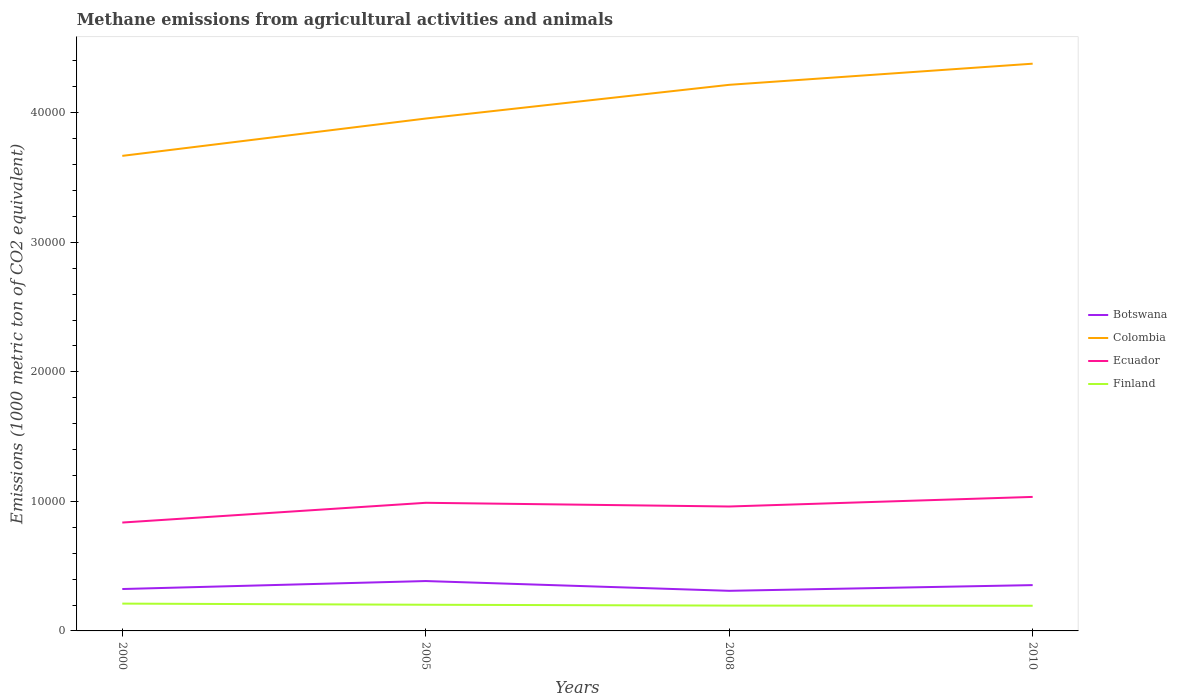Does the line corresponding to Ecuador intersect with the line corresponding to Finland?
Provide a short and direct response. No. Is the number of lines equal to the number of legend labels?
Offer a terse response. Yes. Across all years, what is the maximum amount of methane emitted in Botswana?
Keep it short and to the point. 3096.4. In which year was the amount of methane emitted in Finland maximum?
Keep it short and to the point. 2010. What is the total amount of methane emitted in Colombia in the graph?
Provide a short and direct response. -4235.6. What is the difference between the highest and the second highest amount of methane emitted in Finland?
Make the answer very short. 164.3. What is the difference between the highest and the lowest amount of methane emitted in Finland?
Provide a succinct answer. 2. Is the amount of methane emitted in Finland strictly greater than the amount of methane emitted in Colombia over the years?
Keep it short and to the point. Yes. How many lines are there?
Provide a succinct answer. 4. How many years are there in the graph?
Offer a very short reply. 4. What is the difference between two consecutive major ticks on the Y-axis?
Offer a terse response. 10000. Are the values on the major ticks of Y-axis written in scientific E-notation?
Give a very brief answer. No. Where does the legend appear in the graph?
Ensure brevity in your answer.  Center right. How many legend labels are there?
Your answer should be compact. 4. What is the title of the graph?
Keep it short and to the point. Methane emissions from agricultural activities and animals. Does "Peru" appear as one of the legend labels in the graph?
Keep it short and to the point. No. What is the label or title of the Y-axis?
Your answer should be very brief. Emissions (1000 metric ton of CO2 equivalent). What is the Emissions (1000 metric ton of CO2 equivalent) of Botswana in 2000?
Your answer should be very brief. 3234. What is the Emissions (1000 metric ton of CO2 equivalent) in Colombia in 2000?
Offer a very short reply. 3.67e+04. What is the Emissions (1000 metric ton of CO2 equivalent) in Ecuador in 2000?
Your answer should be very brief. 8366.7. What is the Emissions (1000 metric ton of CO2 equivalent) in Finland in 2000?
Provide a short and direct response. 2107.9. What is the Emissions (1000 metric ton of CO2 equivalent) in Botswana in 2005?
Give a very brief answer. 3850.6. What is the Emissions (1000 metric ton of CO2 equivalent) in Colombia in 2005?
Make the answer very short. 3.96e+04. What is the Emissions (1000 metric ton of CO2 equivalent) in Ecuador in 2005?
Keep it short and to the point. 9891. What is the Emissions (1000 metric ton of CO2 equivalent) in Finland in 2005?
Give a very brief answer. 2020.8. What is the Emissions (1000 metric ton of CO2 equivalent) of Botswana in 2008?
Provide a succinct answer. 3096.4. What is the Emissions (1000 metric ton of CO2 equivalent) of Colombia in 2008?
Keep it short and to the point. 4.22e+04. What is the Emissions (1000 metric ton of CO2 equivalent) of Ecuador in 2008?
Your response must be concise. 9604.8. What is the Emissions (1000 metric ton of CO2 equivalent) of Finland in 2008?
Your answer should be very brief. 1955.7. What is the Emissions (1000 metric ton of CO2 equivalent) in Botswana in 2010?
Your answer should be compact. 3536.6. What is the Emissions (1000 metric ton of CO2 equivalent) in Colombia in 2010?
Your answer should be compact. 4.38e+04. What is the Emissions (1000 metric ton of CO2 equivalent) in Ecuador in 2010?
Your response must be concise. 1.03e+04. What is the Emissions (1000 metric ton of CO2 equivalent) of Finland in 2010?
Offer a very short reply. 1943.6. Across all years, what is the maximum Emissions (1000 metric ton of CO2 equivalent) in Botswana?
Offer a very short reply. 3850.6. Across all years, what is the maximum Emissions (1000 metric ton of CO2 equivalent) of Colombia?
Keep it short and to the point. 4.38e+04. Across all years, what is the maximum Emissions (1000 metric ton of CO2 equivalent) in Ecuador?
Provide a succinct answer. 1.03e+04. Across all years, what is the maximum Emissions (1000 metric ton of CO2 equivalent) in Finland?
Your answer should be very brief. 2107.9. Across all years, what is the minimum Emissions (1000 metric ton of CO2 equivalent) of Botswana?
Give a very brief answer. 3096.4. Across all years, what is the minimum Emissions (1000 metric ton of CO2 equivalent) in Colombia?
Make the answer very short. 3.67e+04. Across all years, what is the minimum Emissions (1000 metric ton of CO2 equivalent) in Ecuador?
Make the answer very short. 8366.7. Across all years, what is the minimum Emissions (1000 metric ton of CO2 equivalent) of Finland?
Give a very brief answer. 1943.6. What is the total Emissions (1000 metric ton of CO2 equivalent) in Botswana in the graph?
Ensure brevity in your answer.  1.37e+04. What is the total Emissions (1000 metric ton of CO2 equivalent) in Colombia in the graph?
Your answer should be very brief. 1.62e+05. What is the total Emissions (1000 metric ton of CO2 equivalent) in Ecuador in the graph?
Your answer should be compact. 3.82e+04. What is the total Emissions (1000 metric ton of CO2 equivalent) of Finland in the graph?
Your answer should be compact. 8028. What is the difference between the Emissions (1000 metric ton of CO2 equivalent) in Botswana in 2000 and that in 2005?
Give a very brief answer. -616.6. What is the difference between the Emissions (1000 metric ton of CO2 equivalent) of Colombia in 2000 and that in 2005?
Your answer should be compact. -2881.6. What is the difference between the Emissions (1000 metric ton of CO2 equivalent) in Ecuador in 2000 and that in 2005?
Provide a short and direct response. -1524.3. What is the difference between the Emissions (1000 metric ton of CO2 equivalent) in Finland in 2000 and that in 2005?
Your answer should be compact. 87.1. What is the difference between the Emissions (1000 metric ton of CO2 equivalent) of Botswana in 2000 and that in 2008?
Your answer should be very brief. 137.6. What is the difference between the Emissions (1000 metric ton of CO2 equivalent) in Colombia in 2000 and that in 2008?
Keep it short and to the point. -5485.2. What is the difference between the Emissions (1000 metric ton of CO2 equivalent) of Ecuador in 2000 and that in 2008?
Offer a terse response. -1238.1. What is the difference between the Emissions (1000 metric ton of CO2 equivalent) of Finland in 2000 and that in 2008?
Offer a terse response. 152.2. What is the difference between the Emissions (1000 metric ton of CO2 equivalent) of Botswana in 2000 and that in 2010?
Offer a terse response. -302.6. What is the difference between the Emissions (1000 metric ton of CO2 equivalent) in Colombia in 2000 and that in 2010?
Ensure brevity in your answer.  -7117.2. What is the difference between the Emissions (1000 metric ton of CO2 equivalent) in Ecuador in 2000 and that in 2010?
Your response must be concise. -1979.1. What is the difference between the Emissions (1000 metric ton of CO2 equivalent) of Finland in 2000 and that in 2010?
Give a very brief answer. 164.3. What is the difference between the Emissions (1000 metric ton of CO2 equivalent) in Botswana in 2005 and that in 2008?
Your answer should be compact. 754.2. What is the difference between the Emissions (1000 metric ton of CO2 equivalent) of Colombia in 2005 and that in 2008?
Your response must be concise. -2603.6. What is the difference between the Emissions (1000 metric ton of CO2 equivalent) in Ecuador in 2005 and that in 2008?
Offer a very short reply. 286.2. What is the difference between the Emissions (1000 metric ton of CO2 equivalent) in Finland in 2005 and that in 2008?
Ensure brevity in your answer.  65.1. What is the difference between the Emissions (1000 metric ton of CO2 equivalent) of Botswana in 2005 and that in 2010?
Make the answer very short. 314. What is the difference between the Emissions (1000 metric ton of CO2 equivalent) of Colombia in 2005 and that in 2010?
Give a very brief answer. -4235.6. What is the difference between the Emissions (1000 metric ton of CO2 equivalent) of Ecuador in 2005 and that in 2010?
Offer a terse response. -454.8. What is the difference between the Emissions (1000 metric ton of CO2 equivalent) in Finland in 2005 and that in 2010?
Offer a very short reply. 77.2. What is the difference between the Emissions (1000 metric ton of CO2 equivalent) of Botswana in 2008 and that in 2010?
Provide a short and direct response. -440.2. What is the difference between the Emissions (1000 metric ton of CO2 equivalent) of Colombia in 2008 and that in 2010?
Ensure brevity in your answer.  -1632. What is the difference between the Emissions (1000 metric ton of CO2 equivalent) in Ecuador in 2008 and that in 2010?
Keep it short and to the point. -741. What is the difference between the Emissions (1000 metric ton of CO2 equivalent) in Finland in 2008 and that in 2010?
Offer a very short reply. 12.1. What is the difference between the Emissions (1000 metric ton of CO2 equivalent) of Botswana in 2000 and the Emissions (1000 metric ton of CO2 equivalent) of Colombia in 2005?
Your answer should be compact. -3.63e+04. What is the difference between the Emissions (1000 metric ton of CO2 equivalent) of Botswana in 2000 and the Emissions (1000 metric ton of CO2 equivalent) of Ecuador in 2005?
Ensure brevity in your answer.  -6657. What is the difference between the Emissions (1000 metric ton of CO2 equivalent) of Botswana in 2000 and the Emissions (1000 metric ton of CO2 equivalent) of Finland in 2005?
Offer a very short reply. 1213.2. What is the difference between the Emissions (1000 metric ton of CO2 equivalent) of Colombia in 2000 and the Emissions (1000 metric ton of CO2 equivalent) of Ecuador in 2005?
Your answer should be compact. 2.68e+04. What is the difference between the Emissions (1000 metric ton of CO2 equivalent) of Colombia in 2000 and the Emissions (1000 metric ton of CO2 equivalent) of Finland in 2005?
Offer a terse response. 3.47e+04. What is the difference between the Emissions (1000 metric ton of CO2 equivalent) of Ecuador in 2000 and the Emissions (1000 metric ton of CO2 equivalent) of Finland in 2005?
Your answer should be compact. 6345.9. What is the difference between the Emissions (1000 metric ton of CO2 equivalent) in Botswana in 2000 and the Emissions (1000 metric ton of CO2 equivalent) in Colombia in 2008?
Your answer should be very brief. -3.89e+04. What is the difference between the Emissions (1000 metric ton of CO2 equivalent) of Botswana in 2000 and the Emissions (1000 metric ton of CO2 equivalent) of Ecuador in 2008?
Give a very brief answer. -6370.8. What is the difference between the Emissions (1000 metric ton of CO2 equivalent) of Botswana in 2000 and the Emissions (1000 metric ton of CO2 equivalent) of Finland in 2008?
Your answer should be compact. 1278.3. What is the difference between the Emissions (1000 metric ton of CO2 equivalent) in Colombia in 2000 and the Emissions (1000 metric ton of CO2 equivalent) in Ecuador in 2008?
Your response must be concise. 2.71e+04. What is the difference between the Emissions (1000 metric ton of CO2 equivalent) of Colombia in 2000 and the Emissions (1000 metric ton of CO2 equivalent) of Finland in 2008?
Offer a terse response. 3.47e+04. What is the difference between the Emissions (1000 metric ton of CO2 equivalent) in Ecuador in 2000 and the Emissions (1000 metric ton of CO2 equivalent) in Finland in 2008?
Offer a terse response. 6411. What is the difference between the Emissions (1000 metric ton of CO2 equivalent) of Botswana in 2000 and the Emissions (1000 metric ton of CO2 equivalent) of Colombia in 2010?
Your answer should be compact. -4.06e+04. What is the difference between the Emissions (1000 metric ton of CO2 equivalent) in Botswana in 2000 and the Emissions (1000 metric ton of CO2 equivalent) in Ecuador in 2010?
Offer a terse response. -7111.8. What is the difference between the Emissions (1000 metric ton of CO2 equivalent) in Botswana in 2000 and the Emissions (1000 metric ton of CO2 equivalent) in Finland in 2010?
Offer a terse response. 1290.4. What is the difference between the Emissions (1000 metric ton of CO2 equivalent) in Colombia in 2000 and the Emissions (1000 metric ton of CO2 equivalent) in Ecuador in 2010?
Keep it short and to the point. 2.63e+04. What is the difference between the Emissions (1000 metric ton of CO2 equivalent) in Colombia in 2000 and the Emissions (1000 metric ton of CO2 equivalent) in Finland in 2010?
Make the answer very short. 3.47e+04. What is the difference between the Emissions (1000 metric ton of CO2 equivalent) of Ecuador in 2000 and the Emissions (1000 metric ton of CO2 equivalent) of Finland in 2010?
Your response must be concise. 6423.1. What is the difference between the Emissions (1000 metric ton of CO2 equivalent) in Botswana in 2005 and the Emissions (1000 metric ton of CO2 equivalent) in Colombia in 2008?
Ensure brevity in your answer.  -3.83e+04. What is the difference between the Emissions (1000 metric ton of CO2 equivalent) in Botswana in 2005 and the Emissions (1000 metric ton of CO2 equivalent) in Ecuador in 2008?
Provide a short and direct response. -5754.2. What is the difference between the Emissions (1000 metric ton of CO2 equivalent) of Botswana in 2005 and the Emissions (1000 metric ton of CO2 equivalent) of Finland in 2008?
Offer a terse response. 1894.9. What is the difference between the Emissions (1000 metric ton of CO2 equivalent) of Colombia in 2005 and the Emissions (1000 metric ton of CO2 equivalent) of Ecuador in 2008?
Keep it short and to the point. 3.00e+04. What is the difference between the Emissions (1000 metric ton of CO2 equivalent) in Colombia in 2005 and the Emissions (1000 metric ton of CO2 equivalent) in Finland in 2008?
Your answer should be compact. 3.76e+04. What is the difference between the Emissions (1000 metric ton of CO2 equivalent) of Ecuador in 2005 and the Emissions (1000 metric ton of CO2 equivalent) of Finland in 2008?
Your response must be concise. 7935.3. What is the difference between the Emissions (1000 metric ton of CO2 equivalent) in Botswana in 2005 and the Emissions (1000 metric ton of CO2 equivalent) in Colombia in 2010?
Make the answer very short. -3.99e+04. What is the difference between the Emissions (1000 metric ton of CO2 equivalent) in Botswana in 2005 and the Emissions (1000 metric ton of CO2 equivalent) in Ecuador in 2010?
Your answer should be compact. -6495.2. What is the difference between the Emissions (1000 metric ton of CO2 equivalent) of Botswana in 2005 and the Emissions (1000 metric ton of CO2 equivalent) of Finland in 2010?
Offer a terse response. 1907. What is the difference between the Emissions (1000 metric ton of CO2 equivalent) in Colombia in 2005 and the Emissions (1000 metric ton of CO2 equivalent) in Ecuador in 2010?
Make the answer very short. 2.92e+04. What is the difference between the Emissions (1000 metric ton of CO2 equivalent) of Colombia in 2005 and the Emissions (1000 metric ton of CO2 equivalent) of Finland in 2010?
Offer a terse response. 3.76e+04. What is the difference between the Emissions (1000 metric ton of CO2 equivalent) in Ecuador in 2005 and the Emissions (1000 metric ton of CO2 equivalent) in Finland in 2010?
Ensure brevity in your answer.  7947.4. What is the difference between the Emissions (1000 metric ton of CO2 equivalent) of Botswana in 2008 and the Emissions (1000 metric ton of CO2 equivalent) of Colombia in 2010?
Offer a very short reply. -4.07e+04. What is the difference between the Emissions (1000 metric ton of CO2 equivalent) in Botswana in 2008 and the Emissions (1000 metric ton of CO2 equivalent) in Ecuador in 2010?
Make the answer very short. -7249.4. What is the difference between the Emissions (1000 metric ton of CO2 equivalent) in Botswana in 2008 and the Emissions (1000 metric ton of CO2 equivalent) in Finland in 2010?
Offer a very short reply. 1152.8. What is the difference between the Emissions (1000 metric ton of CO2 equivalent) in Colombia in 2008 and the Emissions (1000 metric ton of CO2 equivalent) in Ecuador in 2010?
Ensure brevity in your answer.  3.18e+04. What is the difference between the Emissions (1000 metric ton of CO2 equivalent) of Colombia in 2008 and the Emissions (1000 metric ton of CO2 equivalent) of Finland in 2010?
Your response must be concise. 4.02e+04. What is the difference between the Emissions (1000 metric ton of CO2 equivalent) of Ecuador in 2008 and the Emissions (1000 metric ton of CO2 equivalent) of Finland in 2010?
Provide a succinct answer. 7661.2. What is the average Emissions (1000 metric ton of CO2 equivalent) of Botswana per year?
Your response must be concise. 3429.4. What is the average Emissions (1000 metric ton of CO2 equivalent) in Colombia per year?
Your answer should be compact. 4.05e+04. What is the average Emissions (1000 metric ton of CO2 equivalent) of Ecuador per year?
Make the answer very short. 9552.08. What is the average Emissions (1000 metric ton of CO2 equivalent) of Finland per year?
Offer a very short reply. 2007. In the year 2000, what is the difference between the Emissions (1000 metric ton of CO2 equivalent) of Botswana and Emissions (1000 metric ton of CO2 equivalent) of Colombia?
Offer a terse response. -3.34e+04. In the year 2000, what is the difference between the Emissions (1000 metric ton of CO2 equivalent) of Botswana and Emissions (1000 metric ton of CO2 equivalent) of Ecuador?
Your answer should be very brief. -5132.7. In the year 2000, what is the difference between the Emissions (1000 metric ton of CO2 equivalent) of Botswana and Emissions (1000 metric ton of CO2 equivalent) of Finland?
Give a very brief answer. 1126.1. In the year 2000, what is the difference between the Emissions (1000 metric ton of CO2 equivalent) of Colombia and Emissions (1000 metric ton of CO2 equivalent) of Ecuador?
Offer a very short reply. 2.83e+04. In the year 2000, what is the difference between the Emissions (1000 metric ton of CO2 equivalent) in Colombia and Emissions (1000 metric ton of CO2 equivalent) in Finland?
Make the answer very short. 3.46e+04. In the year 2000, what is the difference between the Emissions (1000 metric ton of CO2 equivalent) of Ecuador and Emissions (1000 metric ton of CO2 equivalent) of Finland?
Ensure brevity in your answer.  6258.8. In the year 2005, what is the difference between the Emissions (1000 metric ton of CO2 equivalent) of Botswana and Emissions (1000 metric ton of CO2 equivalent) of Colombia?
Give a very brief answer. -3.57e+04. In the year 2005, what is the difference between the Emissions (1000 metric ton of CO2 equivalent) of Botswana and Emissions (1000 metric ton of CO2 equivalent) of Ecuador?
Provide a succinct answer. -6040.4. In the year 2005, what is the difference between the Emissions (1000 metric ton of CO2 equivalent) in Botswana and Emissions (1000 metric ton of CO2 equivalent) in Finland?
Ensure brevity in your answer.  1829.8. In the year 2005, what is the difference between the Emissions (1000 metric ton of CO2 equivalent) in Colombia and Emissions (1000 metric ton of CO2 equivalent) in Ecuador?
Ensure brevity in your answer.  2.97e+04. In the year 2005, what is the difference between the Emissions (1000 metric ton of CO2 equivalent) of Colombia and Emissions (1000 metric ton of CO2 equivalent) of Finland?
Offer a very short reply. 3.75e+04. In the year 2005, what is the difference between the Emissions (1000 metric ton of CO2 equivalent) in Ecuador and Emissions (1000 metric ton of CO2 equivalent) in Finland?
Ensure brevity in your answer.  7870.2. In the year 2008, what is the difference between the Emissions (1000 metric ton of CO2 equivalent) in Botswana and Emissions (1000 metric ton of CO2 equivalent) in Colombia?
Give a very brief answer. -3.91e+04. In the year 2008, what is the difference between the Emissions (1000 metric ton of CO2 equivalent) in Botswana and Emissions (1000 metric ton of CO2 equivalent) in Ecuador?
Provide a short and direct response. -6508.4. In the year 2008, what is the difference between the Emissions (1000 metric ton of CO2 equivalent) in Botswana and Emissions (1000 metric ton of CO2 equivalent) in Finland?
Keep it short and to the point. 1140.7. In the year 2008, what is the difference between the Emissions (1000 metric ton of CO2 equivalent) of Colombia and Emissions (1000 metric ton of CO2 equivalent) of Ecuador?
Give a very brief answer. 3.26e+04. In the year 2008, what is the difference between the Emissions (1000 metric ton of CO2 equivalent) of Colombia and Emissions (1000 metric ton of CO2 equivalent) of Finland?
Your answer should be very brief. 4.02e+04. In the year 2008, what is the difference between the Emissions (1000 metric ton of CO2 equivalent) in Ecuador and Emissions (1000 metric ton of CO2 equivalent) in Finland?
Provide a succinct answer. 7649.1. In the year 2010, what is the difference between the Emissions (1000 metric ton of CO2 equivalent) of Botswana and Emissions (1000 metric ton of CO2 equivalent) of Colombia?
Your response must be concise. -4.03e+04. In the year 2010, what is the difference between the Emissions (1000 metric ton of CO2 equivalent) of Botswana and Emissions (1000 metric ton of CO2 equivalent) of Ecuador?
Provide a succinct answer. -6809.2. In the year 2010, what is the difference between the Emissions (1000 metric ton of CO2 equivalent) in Botswana and Emissions (1000 metric ton of CO2 equivalent) in Finland?
Provide a short and direct response. 1593. In the year 2010, what is the difference between the Emissions (1000 metric ton of CO2 equivalent) of Colombia and Emissions (1000 metric ton of CO2 equivalent) of Ecuador?
Your response must be concise. 3.34e+04. In the year 2010, what is the difference between the Emissions (1000 metric ton of CO2 equivalent) in Colombia and Emissions (1000 metric ton of CO2 equivalent) in Finland?
Keep it short and to the point. 4.18e+04. In the year 2010, what is the difference between the Emissions (1000 metric ton of CO2 equivalent) of Ecuador and Emissions (1000 metric ton of CO2 equivalent) of Finland?
Your answer should be very brief. 8402.2. What is the ratio of the Emissions (1000 metric ton of CO2 equivalent) in Botswana in 2000 to that in 2005?
Your answer should be compact. 0.84. What is the ratio of the Emissions (1000 metric ton of CO2 equivalent) of Colombia in 2000 to that in 2005?
Make the answer very short. 0.93. What is the ratio of the Emissions (1000 metric ton of CO2 equivalent) in Ecuador in 2000 to that in 2005?
Your answer should be compact. 0.85. What is the ratio of the Emissions (1000 metric ton of CO2 equivalent) in Finland in 2000 to that in 2005?
Offer a terse response. 1.04. What is the ratio of the Emissions (1000 metric ton of CO2 equivalent) in Botswana in 2000 to that in 2008?
Provide a succinct answer. 1.04. What is the ratio of the Emissions (1000 metric ton of CO2 equivalent) of Colombia in 2000 to that in 2008?
Keep it short and to the point. 0.87. What is the ratio of the Emissions (1000 metric ton of CO2 equivalent) of Ecuador in 2000 to that in 2008?
Ensure brevity in your answer.  0.87. What is the ratio of the Emissions (1000 metric ton of CO2 equivalent) of Finland in 2000 to that in 2008?
Offer a very short reply. 1.08. What is the ratio of the Emissions (1000 metric ton of CO2 equivalent) of Botswana in 2000 to that in 2010?
Your answer should be very brief. 0.91. What is the ratio of the Emissions (1000 metric ton of CO2 equivalent) of Colombia in 2000 to that in 2010?
Keep it short and to the point. 0.84. What is the ratio of the Emissions (1000 metric ton of CO2 equivalent) of Ecuador in 2000 to that in 2010?
Provide a short and direct response. 0.81. What is the ratio of the Emissions (1000 metric ton of CO2 equivalent) of Finland in 2000 to that in 2010?
Your response must be concise. 1.08. What is the ratio of the Emissions (1000 metric ton of CO2 equivalent) in Botswana in 2005 to that in 2008?
Your answer should be compact. 1.24. What is the ratio of the Emissions (1000 metric ton of CO2 equivalent) of Colombia in 2005 to that in 2008?
Keep it short and to the point. 0.94. What is the ratio of the Emissions (1000 metric ton of CO2 equivalent) in Ecuador in 2005 to that in 2008?
Ensure brevity in your answer.  1.03. What is the ratio of the Emissions (1000 metric ton of CO2 equivalent) in Finland in 2005 to that in 2008?
Offer a terse response. 1.03. What is the ratio of the Emissions (1000 metric ton of CO2 equivalent) in Botswana in 2005 to that in 2010?
Give a very brief answer. 1.09. What is the ratio of the Emissions (1000 metric ton of CO2 equivalent) in Colombia in 2005 to that in 2010?
Ensure brevity in your answer.  0.9. What is the ratio of the Emissions (1000 metric ton of CO2 equivalent) in Ecuador in 2005 to that in 2010?
Offer a very short reply. 0.96. What is the ratio of the Emissions (1000 metric ton of CO2 equivalent) of Finland in 2005 to that in 2010?
Make the answer very short. 1.04. What is the ratio of the Emissions (1000 metric ton of CO2 equivalent) in Botswana in 2008 to that in 2010?
Offer a very short reply. 0.88. What is the ratio of the Emissions (1000 metric ton of CO2 equivalent) in Colombia in 2008 to that in 2010?
Keep it short and to the point. 0.96. What is the ratio of the Emissions (1000 metric ton of CO2 equivalent) of Ecuador in 2008 to that in 2010?
Make the answer very short. 0.93. What is the difference between the highest and the second highest Emissions (1000 metric ton of CO2 equivalent) in Botswana?
Keep it short and to the point. 314. What is the difference between the highest and the second highest Emissions (1000 metric ton of CO2 equivalent) in Colombia?
Give a very brief answer. 1632. What is the difference between the highest and the second highest Emissions (1000 metric ton of CO2 equivalent) in Ecuador?
Provide a succinct answer. 454.8. What is the difference between the highest and the second highest Emissions (1000 metric ton of CO2 equivalent) in Finland?
Your response must be concise. 87.1. What is the difference between the highest and the lowest Emissions (1000 metric ton of CO2 equivalent) in Botswana?
Provide a short and direct response. 754.2. What is the difference between the highest and the lowest Emissions (1000 metric ton of CO2 equivalent) in Colombia?
Ensure brevity in your answer.  7117.2. What is the difference between the highest and the lowest Emissions (1000 metric ton of CO2 equivalent) in Ecuador?
Offer a terse response. 1979.1. What is the difference between the highest and the lowest Emissions (1000 metric ton of CO2 equivalent) in Finland?
Provide a short and direct response. 164.3. 